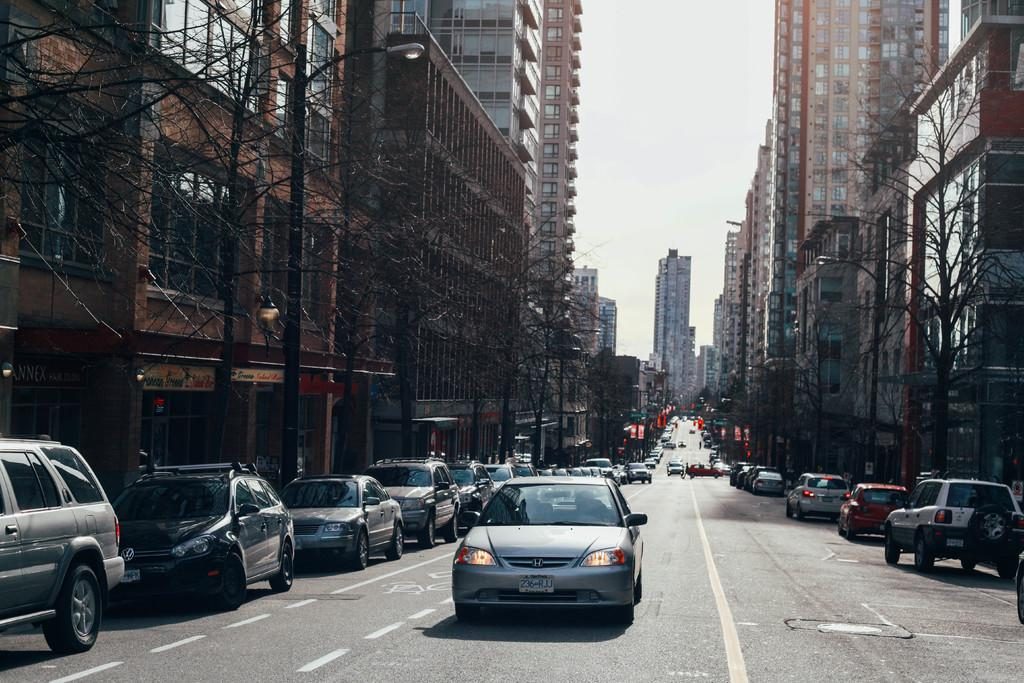What can be seen on the road in the image? There are vehicles on the road in the image. What type of structures are present in the image? There are buildings with windows in the image. What type of vegetation is visible in the image? There are trees in the image. What else can be seen in the image besides the vehicles, buildings, and trees? There are poles in the image. What is visible in the background of the image? The sky is visible in the background of the image. What thought is expressed by the suit in the image? There is no suit present in the image, and therefore no thought can be attributed to it. 